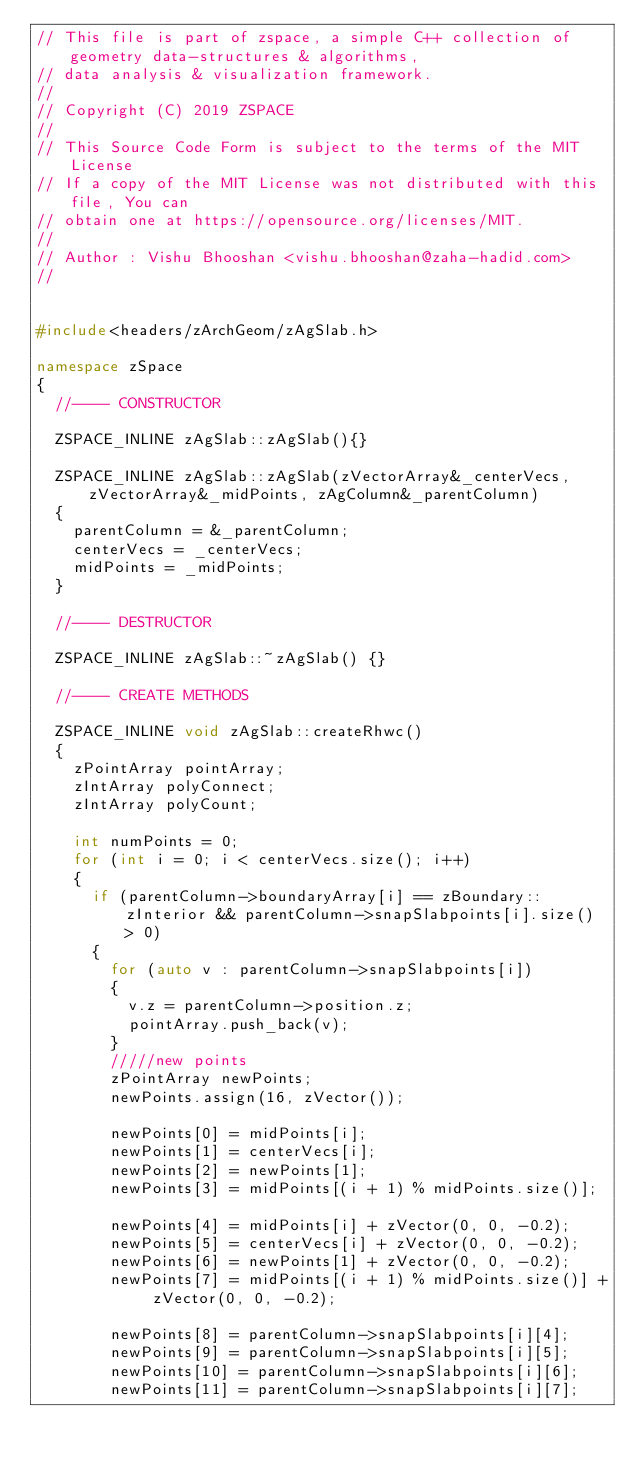<code> <loc_0><loc_0><loc_500><loc_500><_C++_>// This file is part of zspace, a simple C++ collection of geometry data-structures & algorithms, 
// data analysis & visualization framework.
//
// Copyright (C) 2019 ZSPACE 
// 
// This Source Code Form is subject to the terms of the MIT License 
// If a copy of the MIT License was not distributed with this file, You can 
// obtain one at https://opensource.org/licenses/MIT.
//
// Author : Vishu Bhooshan <vishu.bhooshan@zaha-hadid.com>
//


#include<headers/zArchGeom/zAgSlab.h>

namespace zSpace
{
	//---- CONSTRUCTOR

	ZSPACE_INLINE zAgSlab::zAgSlab(){}

	ZSPACE_INLINE zAgSlab::zAgSlab(zVectorArray&_centerVecs, zVectorArray&_midPoints, zAgColumn&_parentColumn)
	{
		parentColumn = &_parentColumn;
		centerVecs = _centerVecs;
		midPoints = _midPoints;
	}

	//---- DESTRUCTOR

	ZSPACE_INLINE zAgSlab::~zAgSlab() {}

	//---- CREATE METHODS

	ZSPACE_INLINE void zAgSlab::createRhwc()
	{
		zPointArray pointArray;
		zIntArray polyConnect;
		zIntArray polyCount;

		int numPoints = 0;
		for (int i = 0; i < centerVecs.size(); i++)
		{
			if (parentColumn->boundaryArray[i] == zBoundary::zInterior && parentColumn->snapSlabpoints[i].size() > 0)
			{
				for (auto v : parentColumn->snapSlabpoints[i])
				{
					v.z = parentColumn->position.z;
					pointArray.push_back(v);
				}
				/////new points 
				zPointArray newPoints;
				newPoints.assign(16, zVector());

				newPoints[0] = midPoints[i];
				newPoints[1] = centerVecs[i];
				newPoints[2] = newPoints[1];
				newPoints[3] = midPoints[(i + 1) % midPoints.size()];

				newPoints[4] = midPoints[i] + zVector(0, 0, -0.2);
				newPoints[5] = centerVecs[i] + zVector(0, 0, -0.2);
				newPoints[6] = newPoints[1] + zVector(0, 0, -0.2);
				newPoints[7] = midPoints[(i + 1) % midPoints.size()] + zVector(0, 0, -0.2);

				newPoints[8] = parentColumn->snapSlabpoints[i][4];
				newPoints[9] = parentColumn->snapSlabpoints[i][5];
				newPoints[10] = parentColumn->snapSlabpoints[i][6];
				newPoints[11] = parentColumn->snapSlabpoints[i][7];
</code> 